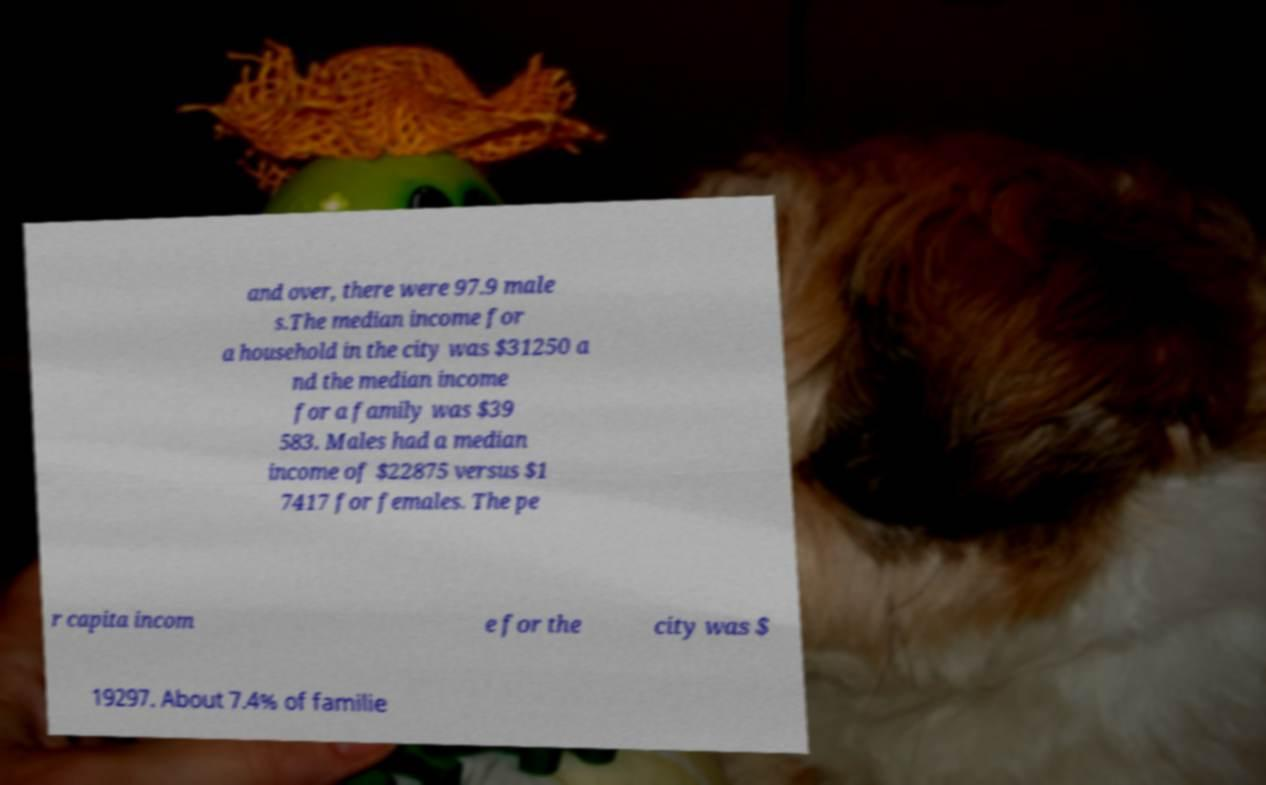Can you accurately transcribe the text from the provided image for me? and over, there were 97.9 male s.The median income for a household in the city was $31250 a nd the median income for a family was $39 583. Males had a median income of $22875 versus $1 7417 for females. The pe r capita incom e for the city was $ 19297. About 7.4% of familie 